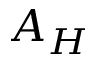Convert formula to latex. <formula><loc_0><loc_0><loc_500><loc_500>A _ { H }</formula> 